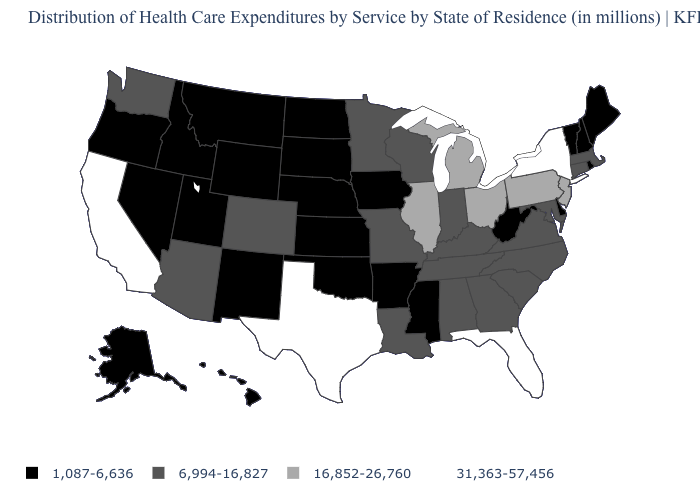Name the states that have a value in the range 16,852-26,760?
Quick response, please. Illinois, Michigan, New Jersey, Ohio, Pennsylvania. Name the states that have a value in the range 1,087-6,636?
Concise answer only. Alaska, Arkansas, Delaware, Hawaii, Idaho, Iowa, Kansas, Maine, Mississippi, Montana, Nebraska, Nevada, New Hampshire, New Mexico, North Dakota, Oklahoma, Oregon, Rhode Island, South Dakota, Utah, Vermont, West Virginia, Wyoming. What is the value of New York?
Short answer required. 31,363-57,456. What is the value of Wyoming?
Give a very brief answer. 1,087-6,636. Does Nevada have the lowest value in the West?
Keep it brief. Yes. Name the states that have a value in the range 31,363-57,456?
Keep it brief. California, Florida, New York, Texas. Name the states that have a value in the range 1,087-6,636?
Be succinct. Alaska, Arkansas, Delaware, Hawaii, Idaho, Iowa, Kansas, Maine, Mississippi, Montana, Nebraska, Nevada, New Hampshire, New Mexico, North Dakota, Oklahoma, Oregon, Rhode Island, South Dakota, Utah, Vermont, West Virginia, Wyoming. What is the highest value in the Northeast ?
Concise answer only. 31,363-57,456. What is the lowest value in states that border Utah?
Be succinct. 1,087-6,636. Name the states that have a value in the range 16,852-26,760?
Give a very brief answer. Illinois, Michigan, New Jersey, Ohio, Pennsylvania. Name the states that have a value in the range 31,363-57,456?
Be succinct. California, Florida, New York, Texas. What is the lowest value in the Northeast?
Short answer required. 1,087-6,636. Does Alabama have the lowest value in the USA?
Be succinct. No. Name the states that have a value in the range 31,363-57,456?
Answer briefly. California, Florida, New York, Texas. 